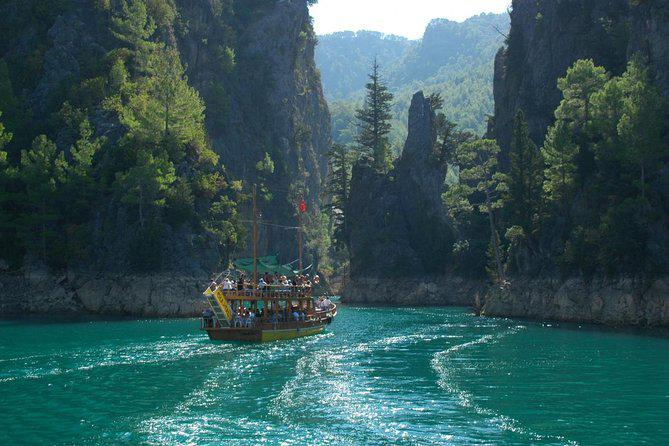How many boats are there in the image? There is one boat in the image, gliding through a narrow passage between towering cliffs, shaded by lush greenery. 